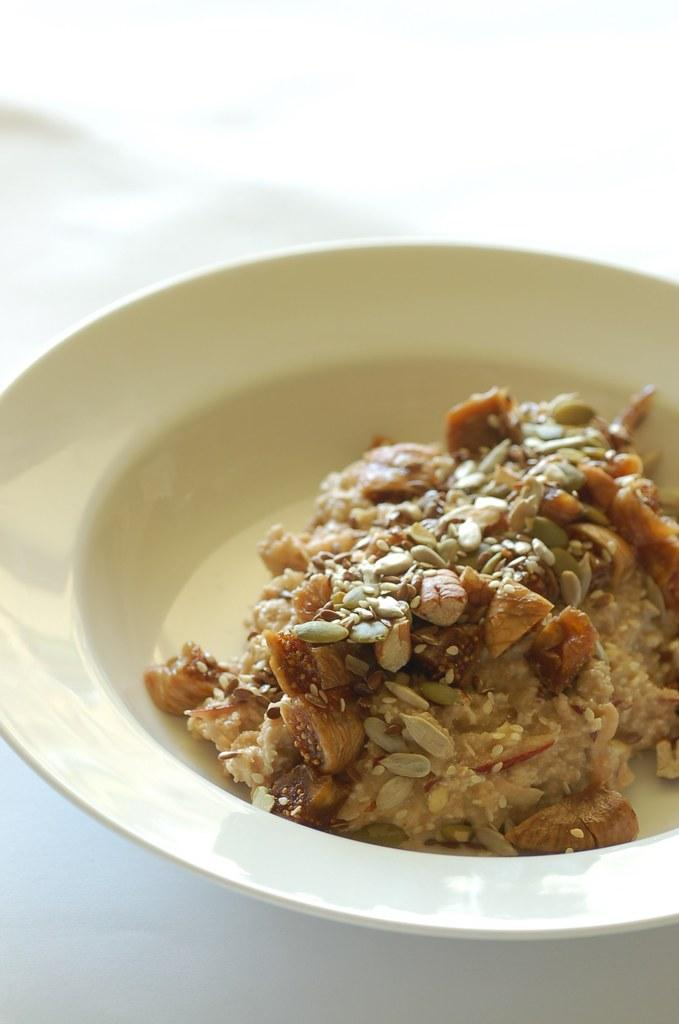What object is present on the plate in the image? There is food on the plate in the image. What can be seen in the background of the image? The background of the image is white. What type of guitar is being played in the image? There is no guitar present in the image; it only features a plate with food and a white background. 